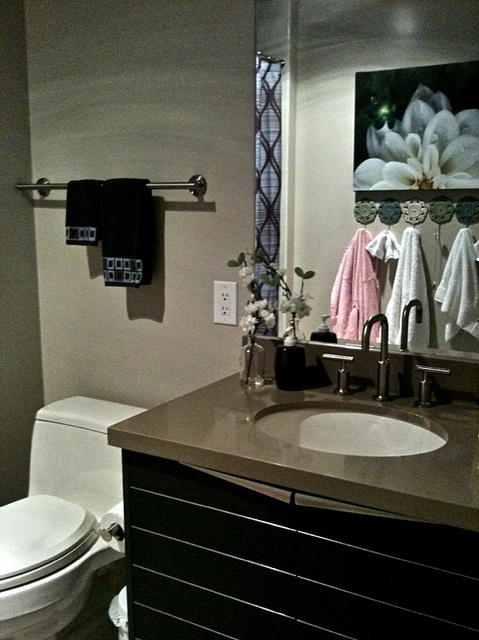Describe the objects in this image and their specific colors. I can see toilet in black, darkgray, ivory, and gray tones, sink in black, darkgray, and gray tones, and vase in black and gray tones in this image. 